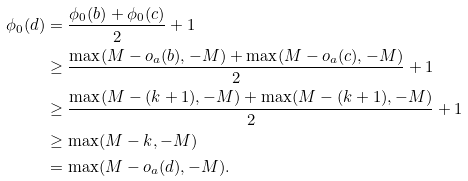<formula> <loc_0><loc_0><loc_500><loc_500>\phi _ { 0 } ( d ) & = \frac { \phi _ { 0 } ( b ) + \phi _ { 0 } ( c ) } { 2 } + 1 \\ & \geq \frac { \max ( M - o _ { a } ( b ) , - M ) + \max ( M - o _ { a } ( c ) , - M ) } { 2 } + 1 \\ & \geq \frac { \max ( M - ( k + 1 ) , - M ) + \max ( M - ( k + 1 ) , - M ) } { 2 } + 1 \\ & \geq \max ( M - k , - M ) \\ & = \max ( M - o _ { a } ( d ) , - M ) .</formula> 